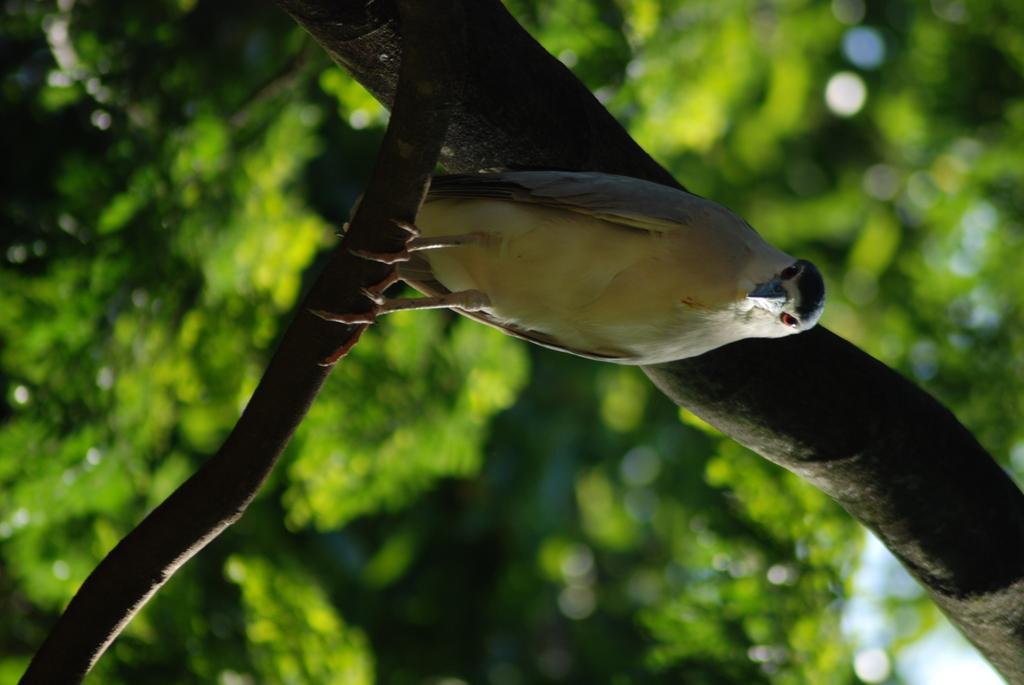Describe this image in one or two sentences. In the foreground of this image, there is a bird on a branch. Behind it, there is trunk of a tree and the background is greenery. 